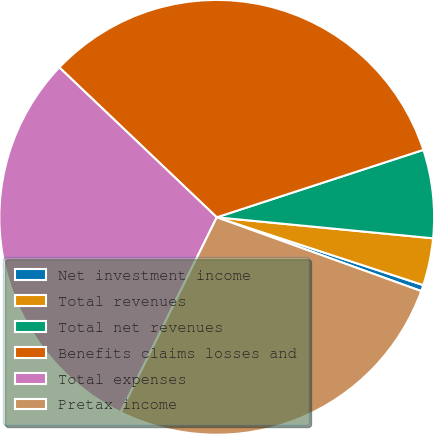Convert chart. <chart><loc_0><loc_0><loc_500><loc_500><pie_chart><fcel>Net investment income<fcel>Total revenues<fcel>Total net revenues<fcel>Benefits claims losses and<fcel>Total expenses<fcel>Pretax income<nl><fcel>0.46%<fcel>3.51%<fcel>6.56%<fcel>32.87%<fcel>29.82%<fcel>26.78%<nl></chart> 